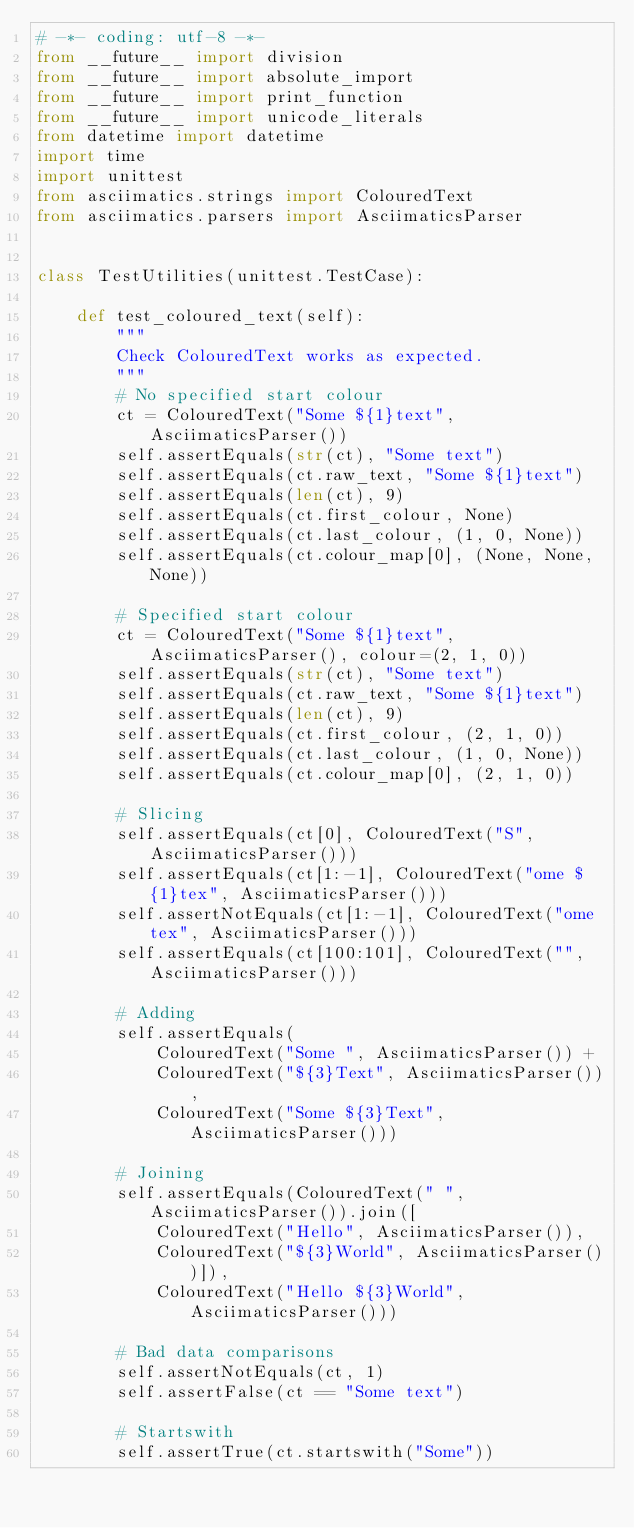<code> <loc_0><loc_0><loc_500><loc_500><_Python_># -*- coding: utf-8 -*-
from __future__ import division
from __future__ import absolute_import
from __future__ import print_function
from __future__ import unicode_literals
from datetime import datetime
import time
import unittest
from asciimatics.strings import ColouredText
from asciimatics.parsers import AsciimaticsParser


class TestUtilities(unittest.TestCase):

    def test_coloured_text(self):
        """
        Check ColouredText works as expected.
        """
        # No specified start colour
        ct = ColouredText("Some ${1}text", AsciimaticsParser())
        self.assertEquals(str(ct), "Some text")
        self.assertEquals(ct.raw_text, "Some ${1}text")
        self.assertEquals(len(ct), 9)
        self.assertEquals(ct.first_colour, None)
        self.assertEquals(ct.last_colour, (1, 0, None))
        self.assertEquals(ct.colour_map[0], (None, None, None))
        
        # Specified start colour
        ct = ColouredText("Some ${1}text", AsciimaticsParser(), colour=(2, 1, 0))
        self.assertEquals(str(ct), "Some text")
        self.assertEquals(ct.raw_text, "Some ${1}text")
        self.assertEquals(len(ct), 9)
        self.assertEquals(ct.first_colour, (2, 1, 0))
        self.assertEquals(ct.last_colour, (1, 0, None))
        self.assertEquals(ct.colour_map[0], (2, 1, 0))

        # Slicing
        self.assertEquals(ct[0], ColouredText("S", AsciimaticsParser()))
        self.assertEquals(ct[1:-1], ColouredText("ome ${1}tex", AsciimaticsParser()))
        self.assertNotEquals(ct[1:-1], ColouredText("ome tex", AsciimaticsParser()))
        self.assertEquals(ct[100:101], ColouredText("", AsciimaticsParser()))

        # Adding
        self.assertEquals(
            ColouredText("Some ", AsciimaticsParser()) +
            ColouredText("${3}Text", AsciimaticsParser()),
            ColouredText("Some ${3}Text", AsciimaticsParser()))

        # Joining
        self.assertEquals(ColouredText(" ", AsciimaticsParser()).join([
            ColouredText("Hello", AsciimaticsParser()),
            ColouredText("${3}World", AsciimaticsParser())]),
            ColouredText("Hello ${3}World", AsciimaticsParser()))

        # Bad data comparisons
        self.assertNotEquals(ct, 1)
        self.assertFalse(ct == "Some text")

        # Startswith
        self.assertTrue(ct.startswith("Some"))
</code> 